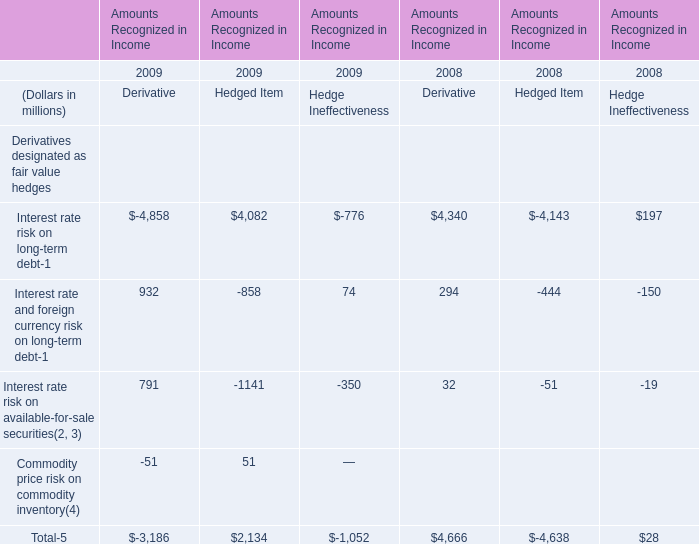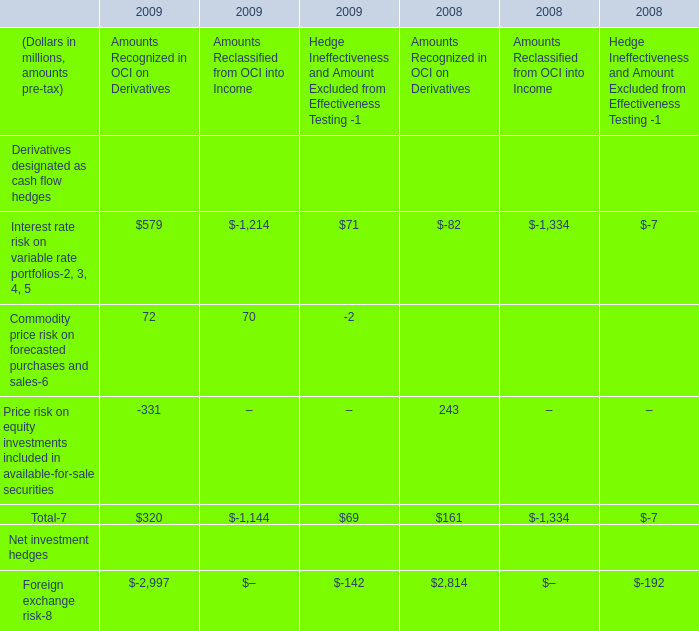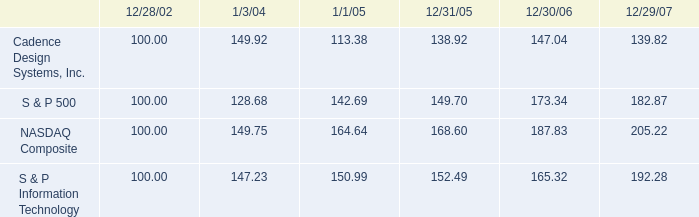what was the percentage cadence design systems , inc . 2019s cumulative 5-year total shareholder return on common stock for the period ending 12/29/07? 
Computations: ((139.82 - 100) / 100)
Answer: 0.3982. 